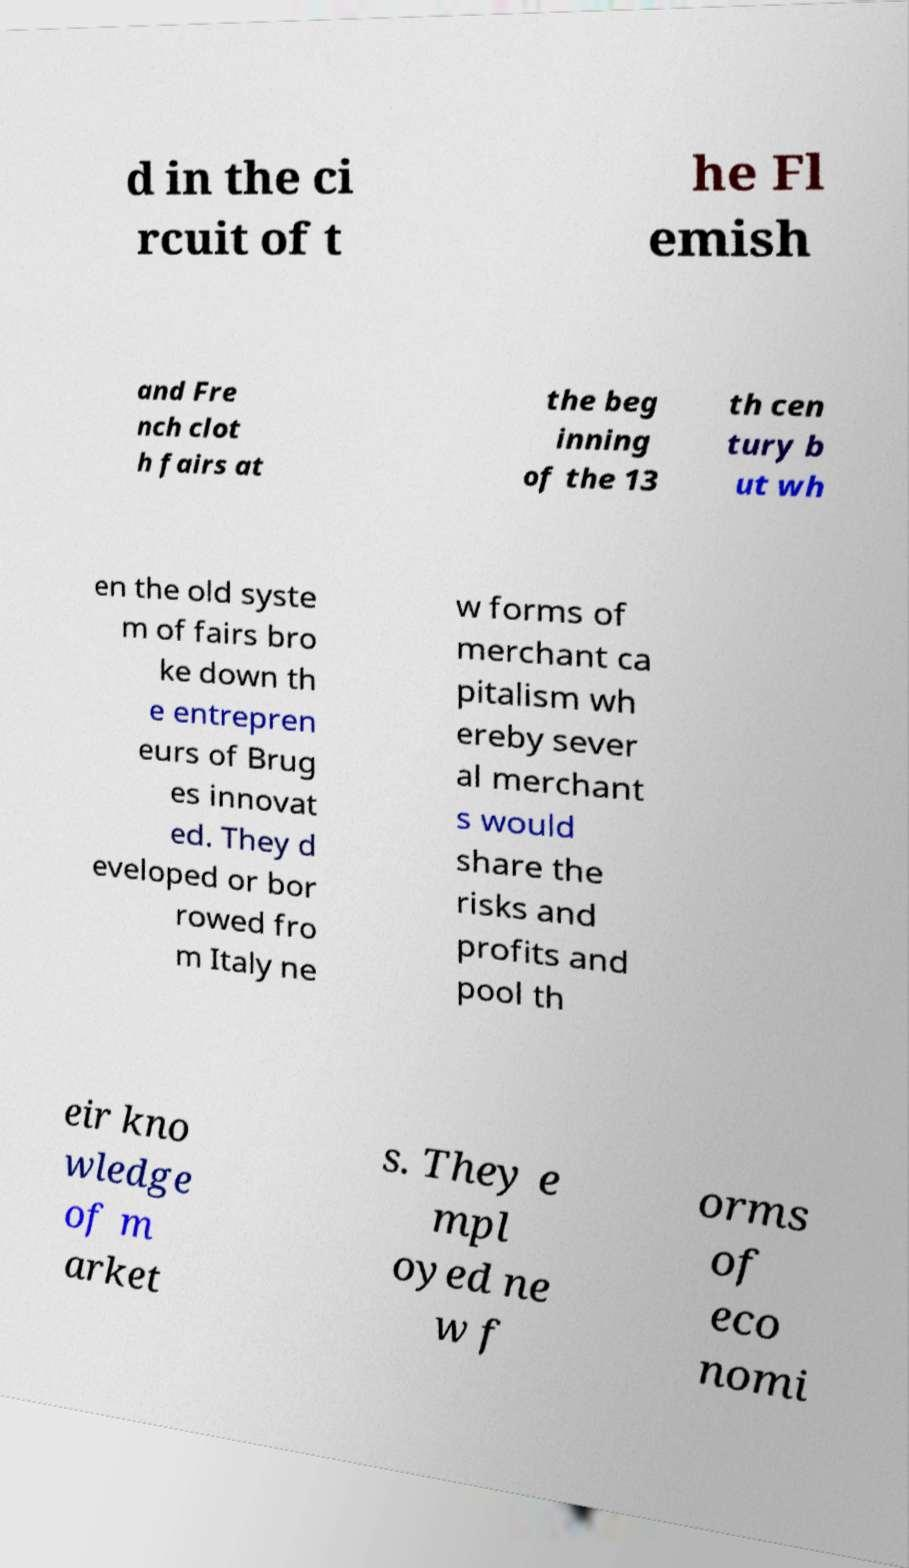Can you accurately transcribe the text from the provided image for me? d in the ci rcuit of t he Fl emish and Fre nch clot h fairs at the beg inning of the 13 th cen tury b ut wh en the old syste m of fairs bro ke down th e entrepren eurs of Brug es innovat ed. They d eveloped or bor rowed fro m Italy ne w forms of merchant ca pitalism wh ereby sever al merchant s would share the risks and profits and pool th eir kno wledge of m arket s. They e mpl oyed ne w f orms of eco nomi 